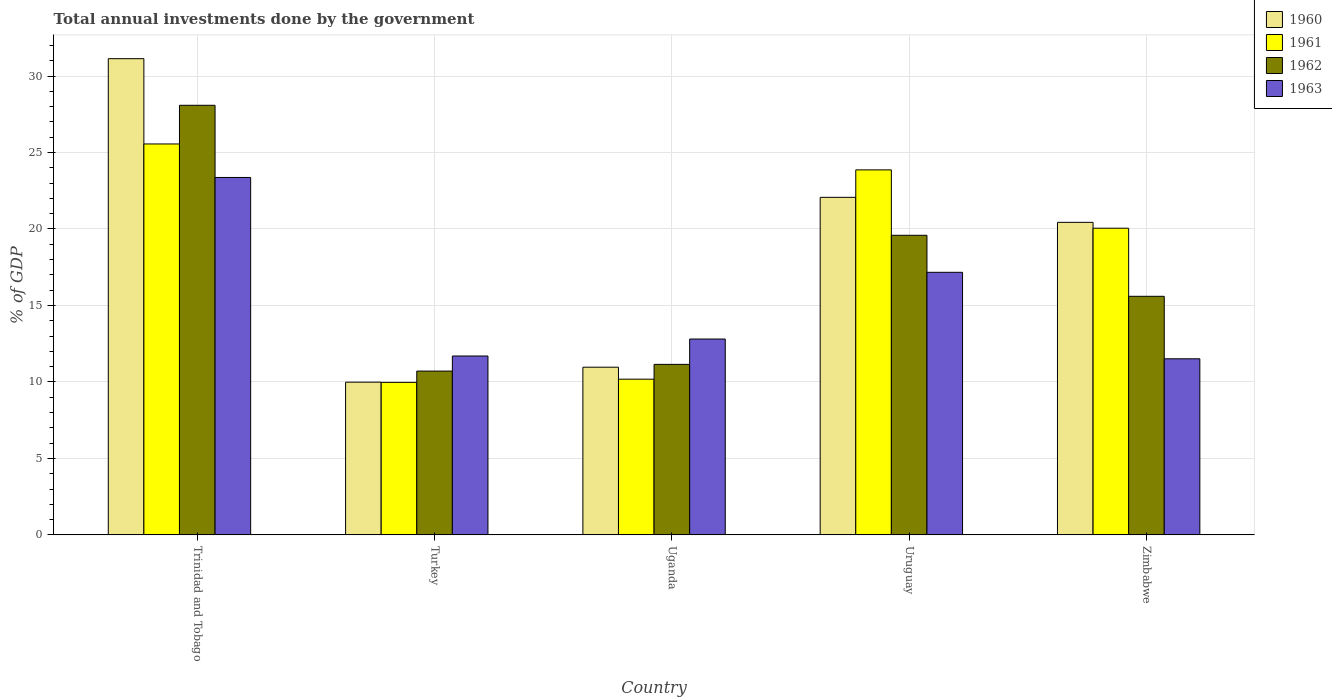How many different coloured bars are there?
Offer a terse response. 4. How many groups of bars are there?
Make the answer very short. 5. Are the number of bars on each tick of the X-axis equal?
Provide a short and direct response. Yes. How many bars are there on the 3rd tick from the left?
Your response must be concise. 4. How many bars are there on the 3rd tick from the right?
Your answer should be very brief. 4. What is the label of the 4th group of bars from the left?
Your answer should be very brief. Uruguay. What is the total annual investments done by the government in 1960 in Uganda?
Offer a terse response. 10.96. Across all countries, what is the maximum total annual investments done by the government in 1962?
Provide a succinct answer. 28.09. Across all countries, what is the minimum total annual investments done by the government in 1960?
Your answer should be very brief. 9.99. In which country was the total annual investments done by the government in 1961 maximum?
Provide a succinct answer. Trinidad and Tobago. In which country was the total annual investments done by the government in 1963 minimum?
Give a very brief answer. Zimbabwe. What is the total total annual investments done by the government in 1962 in the graph?
Your answer should be compact. 85.13. What is the difference between the total annual investments done by the government in 1961 in Uganda and that in Uruguay?
Provide a short and direct response. -13.68. What is the difference between the total annual investments done by the government in 1962 in Uruguay and the total annual investments done by the government in 1961 in Trinidad and Tobago?
Make the answer very short. -5.97. What is the average total annual investments done by the government in 1960 per country?
Make the answer very short. 18.92. What is the difference between the total annual investments done by the government of/in 1960 and total annual investments done by the government of/in 1961 in Uruguay?
Offer a very short reply. -1.79. In how many countries, is the total annual investments done by the government in 1963 greater than 10 %?
Your answer should be very brief. 5. What is the ratio of the total annual investments done by the government in 1960 in Trinidad and Tobago to that in Uganda?
Keep it short and to the point. 2.84. What is the difference between the highest and the second highest total annual investments done by the government in 1960?
Ensure brevity in your answer.  -1.64. What is the difference between the highest and the lowest total annual investments done by the government in 1962?
Keep it short and to the point. 17.38. Is it the case that in every country, the sum of the total annual investments done by the government in 1962 and total annual investments done by the government in 1960 is greater than the sum of total annual investments done by the government in 1963 and total annual investments done by the government in 1961?
Provide a short and direct response. No. What does the 4th bar from the right in Trinidad and Tobago represents?
Make the answer very short. 1960. How many bars are there?
Keep it short and to the point. 20. Are all the bars in the graph horizontal?
Ensure brevity in your answer.  No. How many countries are there in the graph?
Provide a short and direct response. 5. What is the difference between two consecutive major ticks on the Y-axis?
Your answer should be compact. 5. Does the graph contain grids?
Your response must be concise. Yes. How many legend labels are there?
Provide a succinct answer. 4. How are the legend labels stacked?
Provide a short and direct response. Vertical. What is the title of the graph?
Your answer should be very brief. Total annual investments done by the government. Does "2010" appear as one of the legend labels in the graph?
Ensure brevity in your answer.  No. What is the label or title of the X-axis?
Provide a short and direct response. Country. What is the label or title of the Y-axis?
Ensure brevity in your answer.  % of GDP. What is the % of GDP of 1960 in Trinidad and Tobago?
Keep it short and to the point. 31.13. What is the % of GDP in 1961 in Trinidad and Tobago?
Your response must be concise. 25.56. What is the % of GDP of 1962 in Trinidad and Tobago?
Offer a very short reply. 28.09. What is the % of GDP of 1963 in Trinidad and Tobago?
Offer a very short reply. 23.37. What is the % of GDP of 1960 in Turkey?
Provide a short and direct response. 9.99. What is the % of GDP in 1961 in Turkey?
Provide a succinct answer. 9.97. What is the % of GDP in 1962 in Turkey?
Make the answer very short. 10.71. What is the % of GDP of 1963 in Turkey?
Provide a succinct answer. 11.7. What is the % of GDP of 1960 in Uganda?
Make the answer very short. 10.96. What is the % of GDP of 1961 in Uganda?
Your response must be concise. 10.18. What is the % of GDP in 1962 in Uganda?
Your answer should be very brief. 11.15. What is the % of GDP in 1963 in Uganda?
Give a very brief answer. 12.81. What is the % of GDP in 1960 in Uruguay?
Make the answer very short. 22.07. What is the % of GDP in 1961 in Uruguay?
Offer a terse response. 23.86. What is the % of GDP in 1962 in Uruguay?
Your answer should be compact. 19.59. What is the % of GDP of 1963 in Uruguay?
Give a very brief answer. 17.17. What is the % of GDP of 1960 in Zimbabwe?
Keep it short and to the point. 20.43. What is the % of GDP in 1961 in Zimbabwe?
Your answer should be compact. 20.05. What is the % of GDP in 1962 in Zimbabwe?
Offer a terse response. 15.6. What is the % of GDP of 1963 in Zimbabwe?
Keep it short and to the point. 11.51. Across all countries, what is the maximum % of GDP in 1960?
Your answer should be very brief. 31.13. Across all countries, what is the maximum % of GDP of 1961?
Your response must be concise. 25.56. Across all countries, what is the maximum % of GDP in 1962?
Your response must be concise. 28.09. Across all countries, what is the maximum % of GDP in 1963?
Your response must be concise. 23.37. Across all countries, what is the minimum % of GDP in 1960?
Your answer should be very brief. 9.99. Across all countries, what is the minimum % of GDP of 1961?
Ensure brevity in your answer.  9.97. Across all countries, what is the minimum % of GDP of 1962?
Give a very brief answer. 10.71. Across all countries, what is the minimum % of GDP of 1963?
Your answer should be very brief. 11.51. What is the total % of GDP of 1960 in the graph?
Give a very brief answer. 94.59. What is the total % of GDP of 1961 in the graph?
Provide a short and direct response. 89.62. What is the total % of GDP in 1962 in the graph?
Your answer should be very brief. 85.13. What is the total % of GDP of 1963 in the graph?
Offer a very short reply. 76.55. What is the difference between the % of GDP of 1960 in Trinidad and Tobago and that in Turkey?
Provide a succinct answer. 21.15. What is the difference between the % of GDP of 1961 in Trinidad and Tobago and that in Turkey?
Ensure brevity in your answer.  15.59. What is the difference between the % of GDP in 1962 in Trinidad and Tobago and that in Turkey?
Ensure brevity in your answer.  17.38. What is the difference between the % of GDP in 1963 in Trinidad and Tobago and that in Turkey?
Offer a very short reply. 11.67. What is the difference between the % of GDP in 1960 in Trinidad and Tobago and that in Uganda?
Offer a terse response. 20.17. What is the difference between the % of GDP of 1961 in Trinidad and Tobago and that in Uganda?
Offer a very short reply. 15.38. What is the difference between the % of GDP in 1962 in Trinidad and Tobago and that in Uganda?
Offer a terse response. 16.94. What is the difference between the % of GDP in 1963 in Trinidad and Tobago and that in Uganda?
Your answer should be very brief. 10.56. What is the difference between the % of GDP in 1960 in Trinidad and Tobago and that in Uruguay?
Ensure brevity in your answer.  9.06. What is the difference between the % of GDP of 1961 in Trinidad and Tobago and that in Uruguay?
Keep it short and to the point. 1.69. What is the difference between the % of GDP in 1962 in Trinidad and Tobago and that in Uruguay?
Give a very brief answer. 8.5. What is the difference between the % of GDP in 1963 in Trinidad and Tobago and that in Uruguay?
Give a very brief answer. 6.2. What is the difference between the % of GDP of 1960 in Trinidad and Tobago and that in Zimbabwe?
Ensure brevity in your answer.  10.7. What is the difference between the % of GDP of 1961 in Trinidad and Tobago and that in Zimbabwe?
Your response must be concise. 5.51. What is the difference between the % of GDP in 1962 in Trinidad and Tobago and that in Zimbabwe?
Your answer should be very brief. 12.49. What is the difference between the % of GDP in 1963 in Trinidad and Tobago and that in Zimbabwe?
Your answer should be compact. 11.85. What is the difference between the % of GDP in 1960 in Turkey and that in Uganda?
Provide a short and direct response. -0.98. What is the difference between the % of GDP of 1961 in Turkey and that in Uganda?
Keep it short and to the point. -0.21. What is the difference between the % of GDP of 1962 in Turkey and that in Uganda?
Keep it short and to the point. -0.44. What is the difference between the % of GDP in 1963 in Turkey and that in Uganda?
Your answer should be very brief. -1.11. What is the difference between the % of GDP of 1960 in Turkey and that in Uruguay?
Provide a short and direct response. -12.08. What is the difference between the % of GDP of 1961 in Turkey and that in Uruguay?
Provide a short and direct response. -13.89. What is the difference between the % of GDP of 1962 in Turkey and that in Uruguay?
Ensure brevity in your answer.  -8.88. What is the difference between the % of GDP in 1963 in Turkey and that in Uruguay?
Make the answer very short. -5.47. What is the difference between the % of GDP in 1960 in Turkey and that in Zimbabwe?
Your answer should be compact. -10.45. What is the difference between the % of GDP of 1961 in Turkey and that in Zimbabwe?
Make the answer very short. -10.08. What is the difference between the % of GDP of 1962 in Turkey and that in Zimbabwe?
Your answer should be compact. -4.89. What is the difference between the % of GDP in 1963 in Turkey and that in Zimbabwe?
Provide a short and direct response. 0.18. What is the difference between the % of GDP in 1960 in Uganda and that in Uruguay?
Give a very brief answer. -11.1. What is the difference between the % of GDP in 1961 in Uganda and that in Uruguay?
Your answer should be very brief. -13.68. What is the difference between the % of GDP in 1962 in Uganda and that in Uruguay?
Give a very brief answer. -8.44. What is the difference between the % of GDP in 1963 in Uganda and that in Uruguay?
Provide a succinct answer. -4.36. What is the difference between the % of GDP in 1960 in Uganda and that in Zimbabwe?
Give a very brief answer. -9.47. What is the difference between the % of GDP in 1961 in Uganda and that in Zimbabwe?
Offer a terse response. -9.87. What is the difference between the % of GDP of 1962 in Uganda and that in Zimbabwe?
Offer a very short reply. -4.45. What is the difference between the % of GDP in 1963 in Uganda and that in Zimbabwe?
Keep it short and to the point. 1.29. What is the difference between the % of GDP in 1960 in Uruguay and that in Zimbabwe?
Make the answer very short. 1.64. What is the difference between the % of GDP in 1961 in Uruguay and that in Zimbabwe?
Make the answer very short. 3.81. What is the difference between the % of GDP in 1962 in Uruguay and that in Zimbabwe?
Your answer should be very brief. 3.99. What is the difference between the % of GDP of 1963 in Uruguay and that in Zimbabwe?
Ensure brevity in your answer.  5.65. What is the difference between the % of GDP in 1960 in Trinidad and Tobago and the % of GDP in 1961 in Turkey?
Provide a succinct answer. 21.16. What is the difference between the % of GDP in 1960 in Trinidad and Tobago and the % of GDP in 1962 in Turkey?
Offer a very short reply. 20.42. What is the difference between the % of GDP in 1960 in Trinidad and Tobago and the % of GDP in 1963 in Turkey?
Your response must be concise. 19.44. What is the difference between the % of GDP in 1961 in Trinidad and Tobago and the % of GDP in 1962 in Turkey?
Provide a succinct answer. 14.85. What is the difference between the % of GDP in 1961 in Trinidad and Tobago and the % of GDP in 1963 in Turkey?
Your answer should be compact. 13.86. What is the difference between the % of GDP in 1962 in Trinidad and Tobago and the % of GDP in 1963 in Turkey?
Offer a terse response. 16.39. What is the difference between the % of GDP in 1960 in Trinidad and Tobago and the % of GDP in 1961 in Uganda?
Keep it short and to the point. 20.95. What is the difference between the % of GDP of 1960 in Trinidad and Tobago and the % of GDP of 1962 in Uganda?
Keep it short and to the point. 19.99. What is the difference between the % of GDP in 1960 in Trinidad and Tobago and the % of GDP in 1963 in Uganda?
Offer a very short reply. 18.33. What is the difference between the % of GDP of 1961 in Trinidad and Tobago and the % of GDP of 1962 in Uganda?
Offer a very short reply. 14.41. What is the difference between the % of GDP in 1961 in Trinidad and Tobago and the % of GDP in 1963 in Uganda?
Your answer should be compact. 12.75. What is the difference between the % of GDP in 1962 in Trinidad and Tobago and the % of GDP in 1963 in Uganda?
Your answer should be very brief. 15.28. What is the difference between the % of GDP in 1960 in Trinidad and Tobago and the % of GDP in 1961 in Uruguay?
Your response must be concise. 7.27. What is the difference between the % of GDP of 1960 in Trinidad and Tobago and the % of GDP of 1962 in Uruguay?
Your answer should be very brief. 11.55. What is the difference between the % of GDP of 1960 in Trinidad and Tobago and the % of GDP of 1963 in Uruguay?
Keep it short and to the point. 13.97. What is the difference between the % of GDP of 1961 in Trinidad and Tobago and the % of GDP of 1962 in Uruguay?
Make the answer very short. 5.97. What is the difference between the % of GDP in 1961 in Trinidad and Tobago and the % of GDP in 1963 in Uruguay?
Keep it short and to the point. 8.39. What is the difference between the % of GDP of 1962 in Trinidad and Tobago and the % of GDP of 1963 in Uruguay?
Offer a very short reply. 10.92. What is the difference between the % of GDP of 1960 in Trinidad and Tobago and the % of GDP of 1961 in Zimbabwe?
Provide a succinct answer. 11.08. What is the difference between the % of GDP of 1960 in Trinidad and Tobago and the % of GDP of 1962 in Zimbabwe?
Provide a succinct answer. 15.53. What is the difference between the % of GDP in 1960 in Trinidad and Tobago and the % of GDP in 1963 in Zimbabwe?
Ensure brevity in your answer.  19.62. What is the difference between the % of GDP in 1961 in Trinidad and Tobago and the % of GDP in 1962 in Zimbabwe?
Offer a very short reply. 9.96. What is the difference between the % of GDP of 1961 in Trinidad and Tobago and the % of GDP of 1963 in Zimbabwe?
Make the answer very short. 14.05. What is the difference between the % of GDP in 1962 in Trinidad and Tobago and the % of GDP in 1963 in Zimbabwe?
Ensure brevity in your answer.  16.57. What is the difference between the % of GDP of 1960 in Turkey and the % of GDP of 1961 in Uganda?
Offer a very short reply. -0.2. What is the difference between the % of GDP in 1960 in Turkey and the % of GDP in 1962 in Uganda?
Give a very brief answer. -1.16. What is the difference between the % of GDP in 1960 in Turkey and the % of GDP in 1963 in Uganda?
Your answer should be compact. -2.82. What is the difference between the % of GDP of 1961 in Turkey and the % of GDP of 1962 in Uganda?
Offer a terse response. -1.18. What is the difference between the % of GDP of 1961 in Turkey and the % of GDP of 1963 in Uganda?
Provide a succinct answer. -2.83. What is the difference between the % of GDP of 1962 in Turkey and the % of GDP of 1963 in Uganda?
Your answer should be very brief. -2.1. What is the difference between the % of GDP of 1960 in Turkey and the % of GDP of 1961 in Uruguay?
Give a very brief answer. -13.88. What is the difference between the % of GDP in 1960 in Turkey and the % of GDP in 1962 in Uruguay?
Keep it short and to the point. -9.6. What is the difference between the % of GDP in 1960 in Turkey and the % of GDP in 1963 in Uruguay?
Provide a short and direct response. -7.18. What is the difference between the % of GDP of 1961 in Turkey and the % of GDP of 1962 in Uruguay?
Ensure brevity in your answer.  -9.62. What is the difference between the % of GDP of 1961 in Turkey and the % of GDP of 1963 in Uruguay?
Make the answer very short. -7.2. What is the difference between the % of GDP in 1962 in Turkey and the % of GDP in 1963 in Uruguay?
Keep it short and to the point. -6.46. What is the difference between the % of GDP in 1960 in Turkey and the % of GDP in 1961 in Zimbabwe?
Make the answer very short. -10.06. What is the difference between the % of GDP of 1960 in Turkey and the % of GDP of 1962 in Zimbabwe?
Make the answer very short. -5.61. What is the difference between the % of GDP in 1960 in Turkey and the % of GDP in 1963 in Zimbabwe?
Make the answer very short. -1.53. What is the difference between the % of GDP in 1961 in Turkey and the % of GDP in 1962 in Zimbabwe?
Make the answer very short. -5.63. What is the difference between the % of GDP in 1961 in Turkey and the % of GDP in 1963 in Zimbabwe?
Ensure brevity in your answer.  -1.54. What is the difference between the % of GDP in 1962 in Turkey and the % of GDP in 1963 in Zimbabwe?
Give a very brief answer. -0.8. What is the difference between the % of GDP in 1960 in Uganda and the % of GDP in 1961 in Uruguay?
Ensure brevity in your answer.  -12.9. What is the difference between the % of GDP of 1960 in Uganda and the % of GDP of 1962 in Uruguay?
Your answer should be compact. -8.62. What is the difference between the % of GDP in 1960 in Uganda and the % of GDP in 1963 in Uruguay?
Ensure brevity in your answer.  -6.2. What is the difference between the % of GDP of 1961 in Uganda and the % of GDP of 1962 in Uruguay?
Your response must be concise. -9.41. What is the difference between the % of GDP in 1961 in Uganda and the % of GDP in 1963 in Uruguay?
Provide a short and direct response. -6.99. What is the difference between the % of GDP of 1962 in Uganda and the % of GDP of 1963 in Uruguay?
Ensure brevity in your answer.  -6.02. What is the difference between the % of GDP in 1960 in Uganda and the % of GDP in 1961 in Zimbabwe?
Offer a terse response. -9.09. What is the difference between the % of GDP in 1960 in Uganda and the % of GDP in 1962 in Zimbabwe?
Ensure brevity in your answer.  -4.63. What is the difference between the % of GDP of 1960 in Uganda and the % of GDP of 1963 in Zimbabwe?
Your answer should be compact. -0.55. What is the difference between the % of GDP of 1961 in Uganda and the % of GDP of 1962 in Zimbabwe?
Your answer should be compact. -5.42. What is the difference between the % of GDP in 1961 in Uganda and the % of GDP in 1963 in Zimbabwe?
Your answer should be compact. -1.33. What is the difference between the % of GDP of 1962 in Uganda and the % of GDP of 1963 in Zimbabwe?
Offer a terse response. -0.37. What is the difference between the % of GDP in 1960 in Uruguay and the % of GDP in 1961 in Zimbabwe?
Your answer should be compact. 2.02. What is the difference between the % of GDP of 1960 in Uruguay and the % of GDP of 1962 in Zimbabwe?
Make the answer very short. 6.47. What is the difference between the % of GDP of 1960 in Uruguay and the % of GDP of 1963 in Zimbabwe?
Offer a terse response. 10.56. What is the difference between the % of GDP of 1961 in Uruguay and the % of GDP of 1962 in Zimbabwe?
Give a very brief answer. 8.26. What is the difference between the % of GDP of 1961 in Uruguay and the % of GDP of 1963 in Zimbabwe?
Offer a very short reply. 12.35. What is the difference between the % of GDP of 1962 in Uruguay and the % of GDP of 1963 in Zimbabwe?
Your answer should be very brief. 8.07. What is the average % of GDP in 1960 per country?
Ensure brevity in your answer.  18.92. What is the average % of GDP in 1961 per country?
Your answer should be very brief. 17.92. What is the average % of GDP in 1962 per country?
Make the answer very short. 17.03. What is the average % of GDP of 1963 per country?
Offer a terse response. 15.31. What is the difference between the % of GDP in 1960 and % of GDP in 1961 in Trinidad and Tobago?
Offer a very short reply. 5.58. What is the difference between the % of GDP of 1960 and % of GDP of 1962 in Trinidad and Tobago?
Provide a short and direct response. 3.05. What is the difference between the % of GDP of 1960 and % of GDP of 1963 in Trinidad and Tobago?
Offer a very short reply. 7.77. What is the difference between the % of GDP in 1961 and % of GDP in 1962 in Trinidad and Tobago?
Provide a succinct answer. -2.53. What is the difference between the % of GDP of 1961 and % of GDP of 1963 in Trinidad and Tobago?
Keep it short and to the point. 2.19. What is the difference between the % of GDP of 1962 and % of GDP of 1963 in Trinidad and Tobago?
Your answer should be very brief. 4.72. What is the difference between the % of GDP in 1960 and % of GDP in 1961 in Turkey?
Give a very brief answer. 0.01. What is the difference between the % of GDP of 1960 and % of GDP of 1962 in Turkey?
Your answer should be compact. -0.72. What is the difference between the % of GDP in 1960 and % of GDP in 1963 in Turkey?
Provide a short and direct response. -1.71. What is the difference between the % of GDP of 1961 and % of GDP of 1962 in Turkey?
Your answer should be compact. -0.74. What is the difference between the % of GDP of 1961 and % of GDP of 1963 in Turkey?
Ensure brevity in your answer.  -1.72. What is the difference between the % of GDP in 1962 and % of GDP in 1963 in Turkey?
Your answer should be very brief. -0.99. What is the difference between the % of GDP of 1960 and % of GDP of 1961 in Uganda?
Give a very brief answer. 0.78. What is the difference between the % of GDP in 1960 and % of GDP in 1962 in Uganda?
Your response must be concise. -0.18. What is the difference between the % of GDP of 1960 and % of GDP of 1963 in Uganda?
Give a very brief answer. -1.84. What is the difference between the % of GDP in 1961 and % of GDP in 1962 in Uganda?
Your response must be concise. -0.97. What is the difference between the % of GDP of 1961 and % of GDP of 1963 in Uganda?
Provide a short and direct response. -2.63. What is the difference between the % of GDP of 1962 and % of GDP of 1963 in Uganda?
Provide a succinct answer. -1.66. What is the difference between the % of GDP of 1960 and % of GDP of 1961 in Uruguay?
Your response must be concise. -1.79. What is the difference between the % of GDP in 1960 and % of GDP in 1962 in Uruguay?
Your response must be concise. 2.48. What is the difference between the % of GDP of 1960 and % of GDP of 1963 in Uruguay?
Make the answer very short. 4.9. What is the difference between the % of GDP of 1961 and % of GDP of 1962 in Uruguay?
Your response must be concise. 4.28. What is the difference between the % of GDP in 1961 and % of GDP in 1963 in Uruguay?
Provide a succinct answer. 6.7. What is the difference between the % of GDP in 1962 and % of GDP in 1963 in Uruguay?
Your answer should be compact. 2.42. What is the difference between the % of GDP of 1960 and % of GDP of 1961 in Zimbabwe?
Keep it short and to the point. 0.38. What is the difference between the % of GDP of 1960 and % of GDP of 1962 in Zimbabwe?
Your answer should be very brief. 4.84. What is the difference between the % of GDP in 1960 and % of GDP in 1963 in Zimbabwe?
Your answer should be compact. 8.92. What is the difference between the % of GDP of 1961 and % of GDP of 1962 in Zimbabwe?
Offer a very short reply. 4.45. What is the difference between the % of GDP of 1961 and % of GDP of 1963 in Zimbabwe?
Your answer should be compact. 8.54. What is the difference between the % of GDP of 1962 and % of GDP of 1963 in Zimbabwe?
Provide a short and direct response. 4.09. What is the ratio of the % of GDP of 1960 in Trinidad and Tobago to that in Turkey?
Give a very brief answer. 3.12. What is the ratio of the % of GDP of 1961 in Trinidad and Tobago to that in Turkey?
Your answer should be very brief. 2.56. What is the ratio of the % of GDP in 1962 in Trinidad and Tobago to that in Turkey?
Make the answer very short. 2.62. What is the ratio of the % of GDP in 1963 in Trinidad and Tobago to that in Turkey?
Ensure brevity in your answer.  2. What is the ratio of the % of GDP of 1960 in Trinidad and Tobago to that in Uganda?
Provide a succinct answer. 2.84. What is the ratio of the % of GDP in 1961 in Trinidad and Tobago to that in Uganda?
Offer a very short reply. 2.51. What is the ratio of the % of GDP of 1962 in Trinidad and Tobago to that in Uganda?
Your answer should be very brief. 2.52. What is the ratio of the % of GDP of 1963 in Trinidad and Tobago to that in Uganda?
Make the answer very short. 1.82. What is the ratio of the % of GDP of 1960 in Trinidad and Tobago to that in Uruguay?
Provide a succinct answer. 1.41. What is the ratio of the % of GDP in 1961 in Trinidad and Tobago to that in Uruguay?
Make the answer very short. 1.07. What is the ratio of the % of GDP in 1962 in Trinidad and Tobago to that in Uruguay?
Your response must be concise. 1.43. What is the ratio of the % of GDP in 1963 in Trinidad and Tobago to that in Uruguay?
Give a very brief answer. 1.36. What is the ratio of the % of GDP in 1960 in Trinidad and Tobago to that in Zimbabwe?
Make the answer very short. 1.52. What is the ratio of the % of GDP in 1961 in Trinidad and Tobago to that in Zimbabwe?
Provide a succinct answer. 1.27. What is the ratio of the % of GDP in 1962 in Trinidad and Tobago to that in Zimbabwe?
Offer a very short reply. 1.8. What is the ratio of the % of GDP in 1963 in Trinidad and Tobago to that in Zimbabwe?
Offer a terse response. 2.03. What is the ratio of the % of GDP in 1960 in Turkey to that in Uganda?
Provide a succinct answer. 0.91. What is the ratio of the % of GDP in 1961 in Turkey to that in Uganda?
Offer a terse response. 0.98. What is the ratio of the % of GDP of 1962 in Turkey to that in Uganda?
Offer a very short reply. 0.96. What is the ratio of the % of GDP of 1963 in Turkey to that in Uganda?
Keep it short and to the point. 0.91. What is the ratio of the % of GDP in 1960 in Turkey to that in Uruguay?
Give a very brief answer. 0.45. What is the ratio of the % of GDP of 1961 in Turkey to that in Uruguay?
Your response must be concise. 0.42. What is the ratio of the % of GDP of 1962 in Turkey to that in Uruguay?
Offer a very short reply. 0.55. What is the ratio of the % of GDP of 1963 in Turkey to that in Uruguay?
Give a very brief answer. 0.68. What is the ratio of the % of GDP of 1960 in Turkey to that in Zimbabwe?
Ensure brevity in your answer.  0.49. What is the ratio of the % of GDP of 1961 in Turkey to that in Zimbabwe?
Ensure brevity in your answer.  0.5. What is the ratio of the % of GDP in 1962 in Turkey to that in Zimbabwe?
Provide a succinct answer. 0.69. What is the ratio of the % of GDP of 1963 in Turkey to that in Zimbabwe?
Your answer should be very brief. 1.02. What is the ratio of the % of GDP in 1960 in Uganda to that in Uruguay?
Your answer should be compact. 0.5. What is the ratio of the % of GDP of 1961 in Uganda to that in Uruguay?
Offer a terse response. 0.43. What is the ratio of the % of GDP in 1962 in Uganda to that in Uruguay?
Provide a succinct answer. 0.57. What is the ratio of the % of GDP in 1963 in Uganda to that in Uruguay?
Your response must be concise. 0.75. What is the ratio of the % of GDP of 1960 in Uganda to that in Zimbabwe?
Provide a succinct answer. 0.54. What is the ratio of the % of GDP of 1961 in Uganda to that in Zimbabwe?
Keep it short and to the point. 0.51. What is the ratio of the % of GDP of 1962 in Uganda to that in Zimbabwe?
Make the answer very short. 0.71. What is the ratio of the % of GDP in 1963 in Uganda to that in Zimbabwe?
Your answer should be very brief. 1.11. What is the ratio of the % of GDP in 1960 in Uruguay to that in Zimbabwe?
Provide a short and direct response. 1.08. What is the ratio of the % of GDP in 1961 in Uruguay to that in Zimbabwe?
Your response must be concise. 1.19. What is the ratio of the % of GDP of 1962 in Uruguay to that in Zimbabwe?
Your answer should be very brief. 1.26. What is the ratio of the % of GDP of 1963 in Uruguay to that in Zimbabwe?
Provide a short and direct response. 1.49. What is the difference between the highest and the second highest % of GDP of 1960?
Your answer should be compact. 9.06. What is the difference between the highest and the second highest % of GDP in 1961?
Your answer should be compact. 1.69. What is the difference between the highest and the second highest % of GDP in 1962?
Your response must be concise. 8.5. What is the difference between the highest and the second highest % of GDP in 1963?
Offer a terse response. 6.2. What is the difference between the highest and the lowest % of GDP of 1960?
Ensure brevity in your answer.  21.15. What is the difference between the highest and the lowest % of GDP of 1961?
Keep it short and to the point. 15.59. What is the difference between the highest and the lowest % of GDP of 1962?
Offer a terse response. 17.38. What is the difference between the highest and the lowest % of GDP in 1963?
Offer a very short reply. 11.85. 